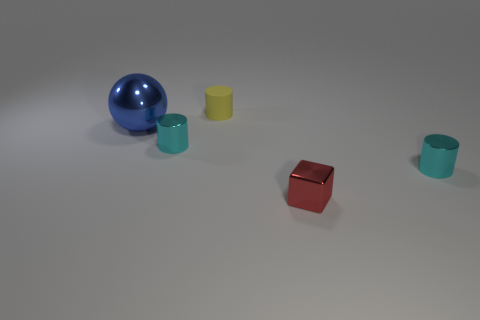Can you describe the colors of the objects in the image? Certainly! In the image, there is a large blue sphere, a smaller red cube, and three cylindrical objects appearing in teal, yellow, and teal, respectively. 